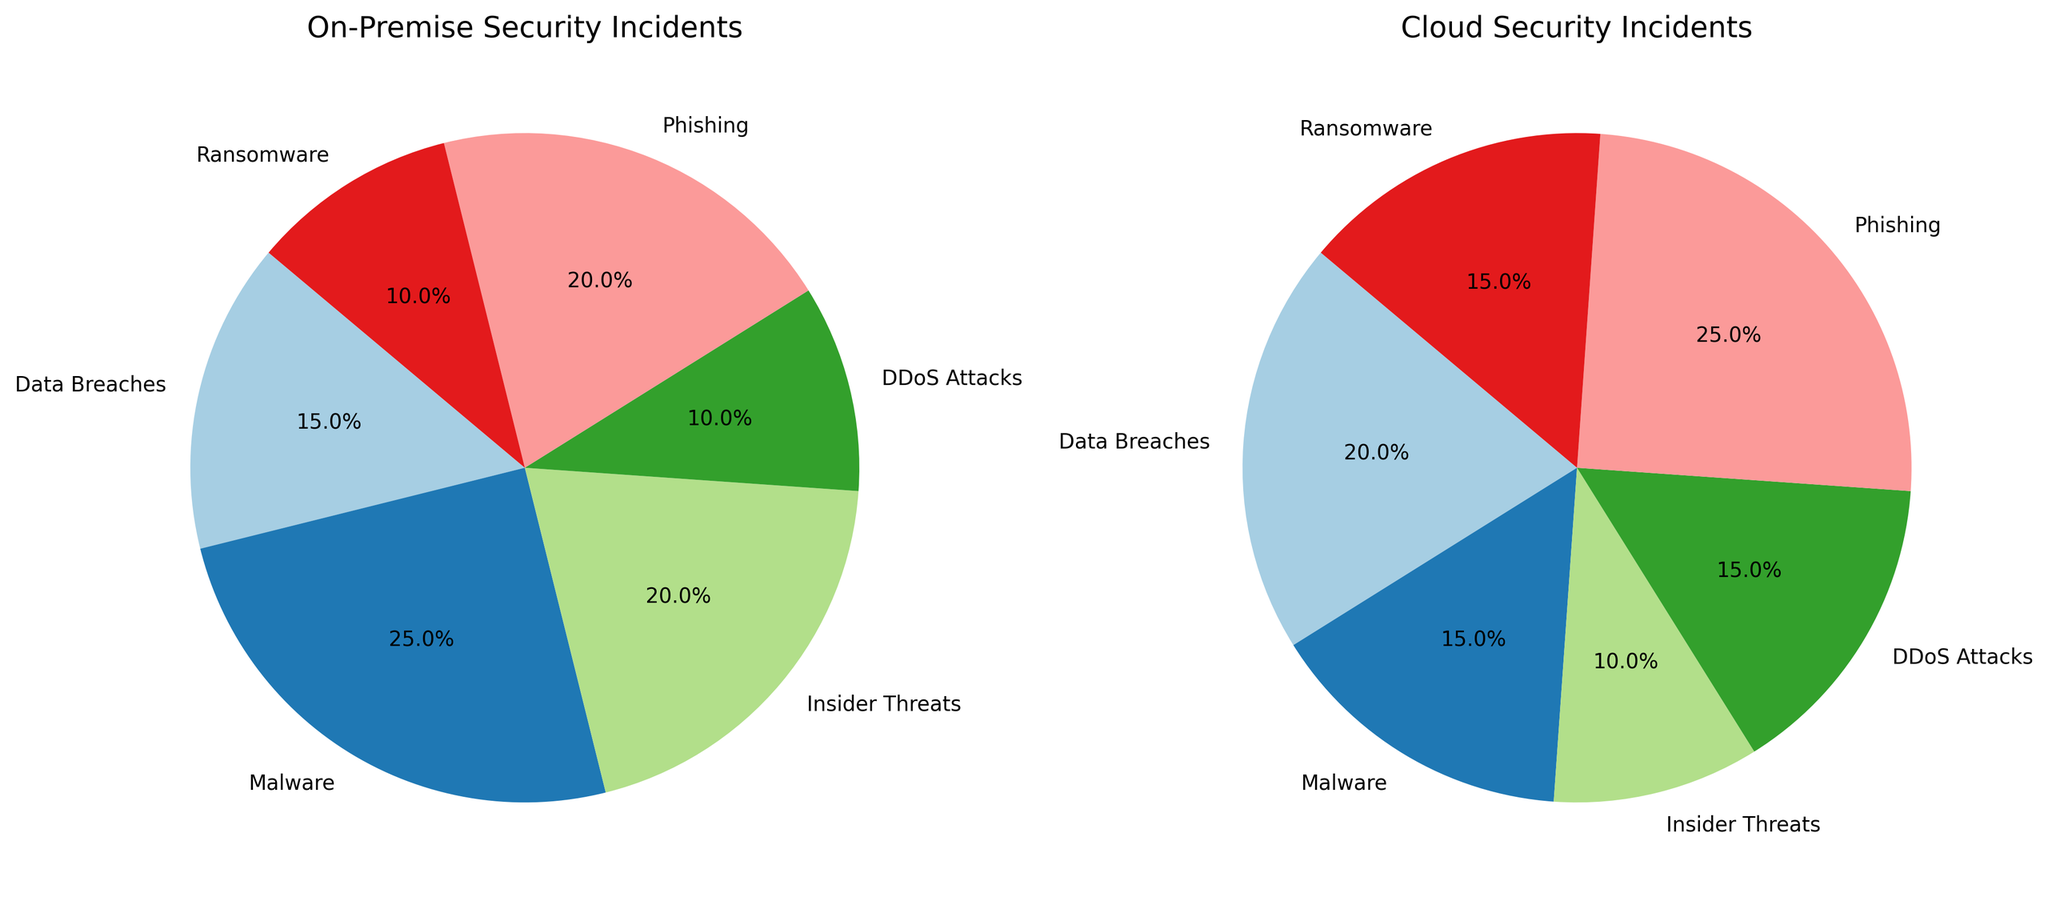What is the most common type of security incident for on-premise environments? By examining the pie chart for On-Premise Security Incidents, it's clear that Malware incidents occupy the largest segment
Answer: Malware Which type of security incident has the highest frequency in cloud environments? By looking at the pie chart for Cloud Security Incidents, Phishing incidents make up the largest portion
Answer: Phishing Compare the percentage of Data Breaches in on-premise vs cloud environments. Data Breaches account for 15% in on-premise environments and 20% in cloud environments, indicating that they are more frequent in cloud environments
Answer: Cloud more Sum the percentages of Insider Threats and Ransomware in on-premise environments. For on-premise environments: Insider Threats = 20% and Ransomware = 10%. Summing these gives 20% + 10% = 30%
Answer: 30% What is the difference in percentage points between Malware incidents in on-premise and cloud environments? On-premise environments have 25% Malware incidents whereas cloud environments have 15%, so the difference is 25% - 15% = 10%
Answer: 10% Which environments have a higher percentage of DDoS Attacks? DDoS Attacks constitute 10% of on-premise incidents and 15% of cloud incidents, making DDoS attacks more prevalent in cloud environments
Answer: Cloud In the on-premise environment, which two types of incidents have the same percentage share? The pie chart for On-Premise shows that both Phishing and Insider Threats incidents have the same percentage share, each at 20%
Answer: Phishing and Insider Threats Which security incident type makes up a quarter of all incidents in cloud environments? The pie chart indicates Phishing accounts for 25% of security incidents in cloud environments
Answer: Phishing What percentage of total cloud security incidents are accounted for by Data Breaches and Malware combined? Data Breaches and Malware make up 20% and 15% in cloud environments respectively. Their combined percentage is 20% + 15% = 35%
Answer: 35% 